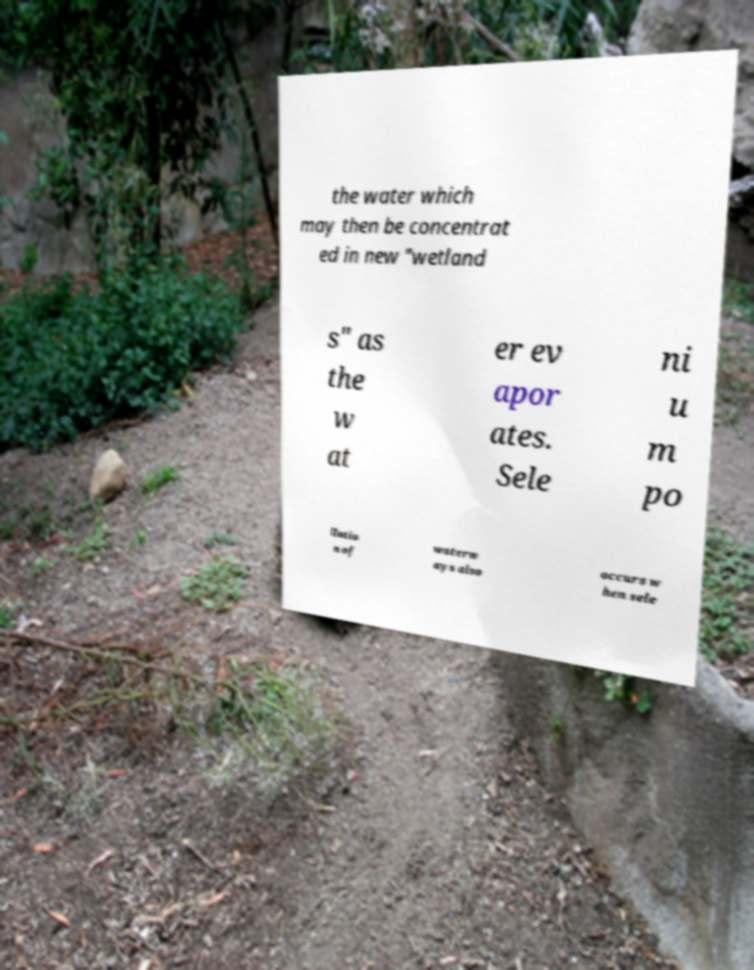What messages or text are displayed in this image? I need them in a readable, typed format. the water which may then be concentrat ed in new "wetland s" as the w at er ev apor ates. Sele ni u m po llutio n of waterw ays also occurs w hen sele 